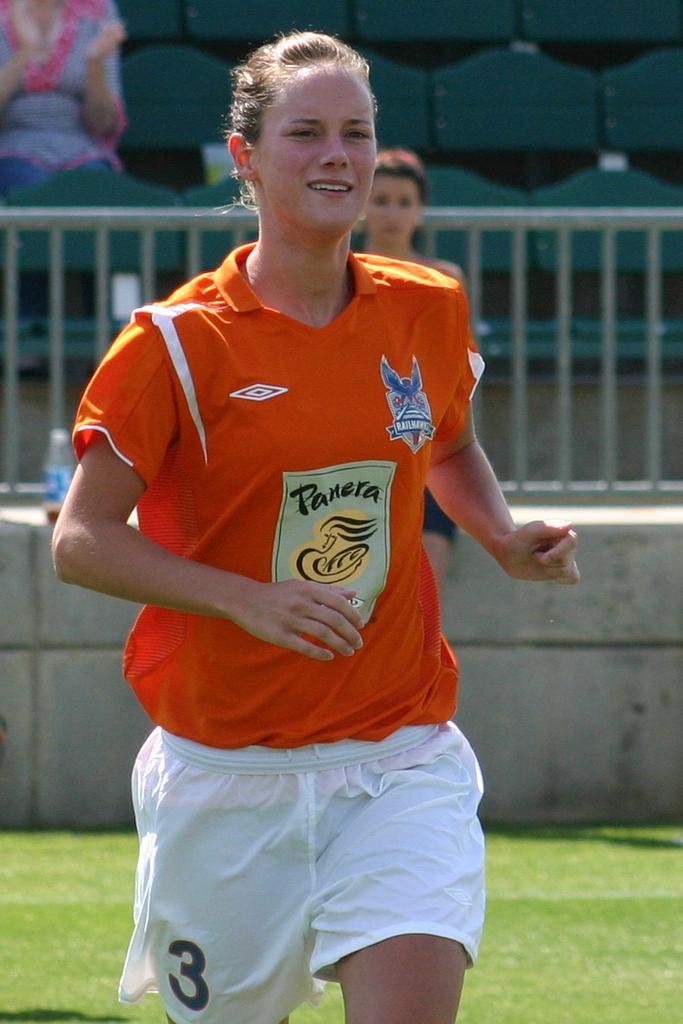<image>
Summarize the visual content of the image. A soccer player wears an orange jersey that is sponsored by Panera. 